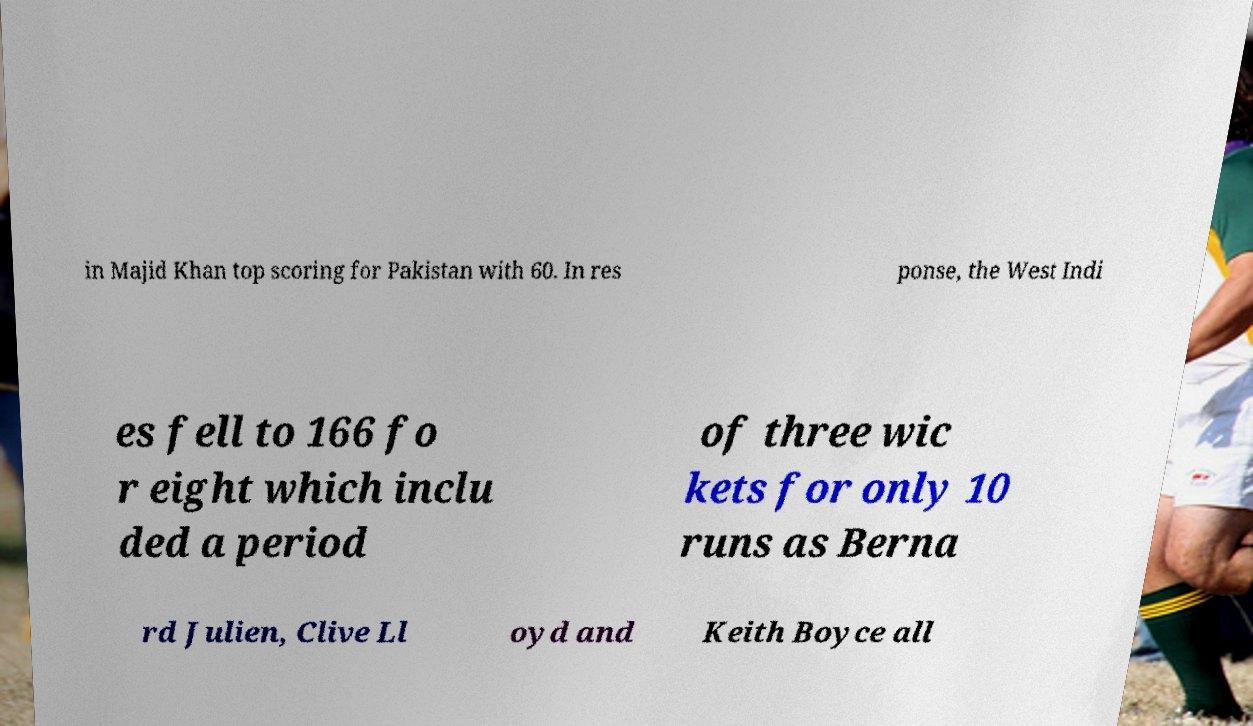What messages or text are displayed in this image? I need them in a readable, typed format. in Majid Khan top scoring for Pakistan with 60. In res ponse, the West Indi es fell to 166 fo r eight which inclu ded a period of three wic kets for only 10 runs as Berna rd Julien, Clive Ll oyd and Keith Boyce all 